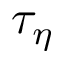Convert formula to latex. <formula><loc_0><loc_0><loc_500><loc_500>\tau _ { \eta }</formula> 